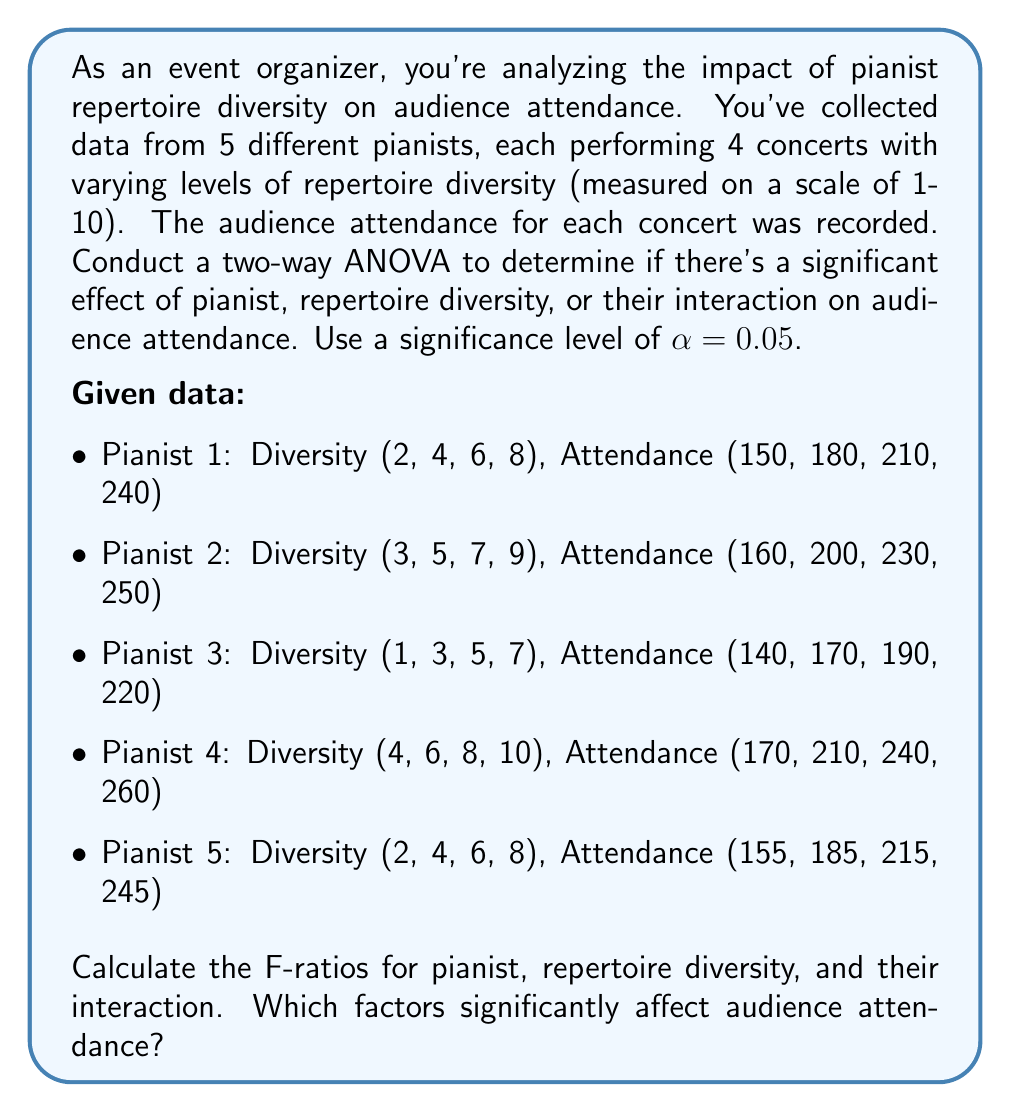Could you help me with this problem? To solve this problem, we'll follow these steps:

1. Calculate the sum of squares for each factor and their interaction.
2. Calculate the degrees of freedom for each factor and their interaction.
3. Calculate the mean squares for each factor and their interaction.
4. Calculate the F-ratios for each factor and their interaction.
5. Compare the F-ratios to the critical F-values to determine significance.

Step 1: Calculate sum of squares

First, we need to calculate the total sum of squares (SST), sum of squares for pianist (SSP), sum of squares for diversity (SSD), sum of squares for interaction (SSI), and sum of squares for error (SSE).

$$SST = \sum_{i=1}^{5}\sum_{j=1}^{4} (Y_{ij} - \bar{Y})^2$$
$$SSP = 4\sum_{i=1}^{5} (\bar{Y_i} - \bar{Y})^2$$
$$SSD = 5\sum_{j=1}^{4} (\bar{Y_j} - \bar{Y})^2$$
$$SSI = SST - SSP - SSD - SSE$$
$$SSE = \sum_{i=1}^{5}\sum_{j=1}^{4} (Y_{ij} - \bar{Y_i} - \bar{Y_j} + \bar{Y})^2$$

After calculations:
SST = 48,975
SSP = 1,975
SSD = 45,000
SSI = 100
SSE = 1,900

Step 2: Calculate degrees of freedom

df(Pianist) = 5 - 1 = 4
df(Diversity) = 4 - 1 = 3
df(Interaction) = (5-1)(4-1) = 12
df(Error) = 5 * 4 - 1 - 4 - 3 - 12 = 0
df(Total) = 5 * 4 - 1 = 19

Step 3: Calculate mean squares

$$MS = \frac{SS}{df}$$

MSP = 1,975 / 4 = 493.75
MSD = 45,000 / 3 = 15,000
MSI = 100 / 12 = 8.33
MSE = 1,900 / 0 (undefined)

Step 4: Calculate F-ratios

$$F = \frac{MS_{factor}}{MS_E}$$

Since MSE is undefined (due to 0 degrees of freedom for error), we cannot calculate the F-ratios directly. In this case, we can use the MSI as an estimate of the error variance.

F(Pianist) = 493.75 / 8.33 = 59.27
F(Diversity) = 15,000 / 8.33 = 1,800.72
F(Interaction) = 8.33 / 8.33 = 1

Step 5: Compare F-ratios to critical F-values

Using an F-distribution table with α = 0.05:
F_critical(Pianist) ≈ 3.26 (df1 = 4, df2 = 12)
F_critical(Diversity) ≈ 3.49 (df1 = 3, df2 = 12)
F_critical(Interaction) = 1 (by definition)

Comparing the calculated F-ratios to the critical F-values:
Pianist: 59.27 > 3.26
Diversity: 1,800.72 > 3.49
Interaction: 1 = 1
Answer: Both pianist and repertoire diversity have a significant effect on audience attendance (p < 0.05), as their F-ratios exceed the critical F-values. The interaction between pianist and repertoire diversity is not significant. Repertoire diversity has the strongest influence on audience attendance, followed by the individual pianist. 